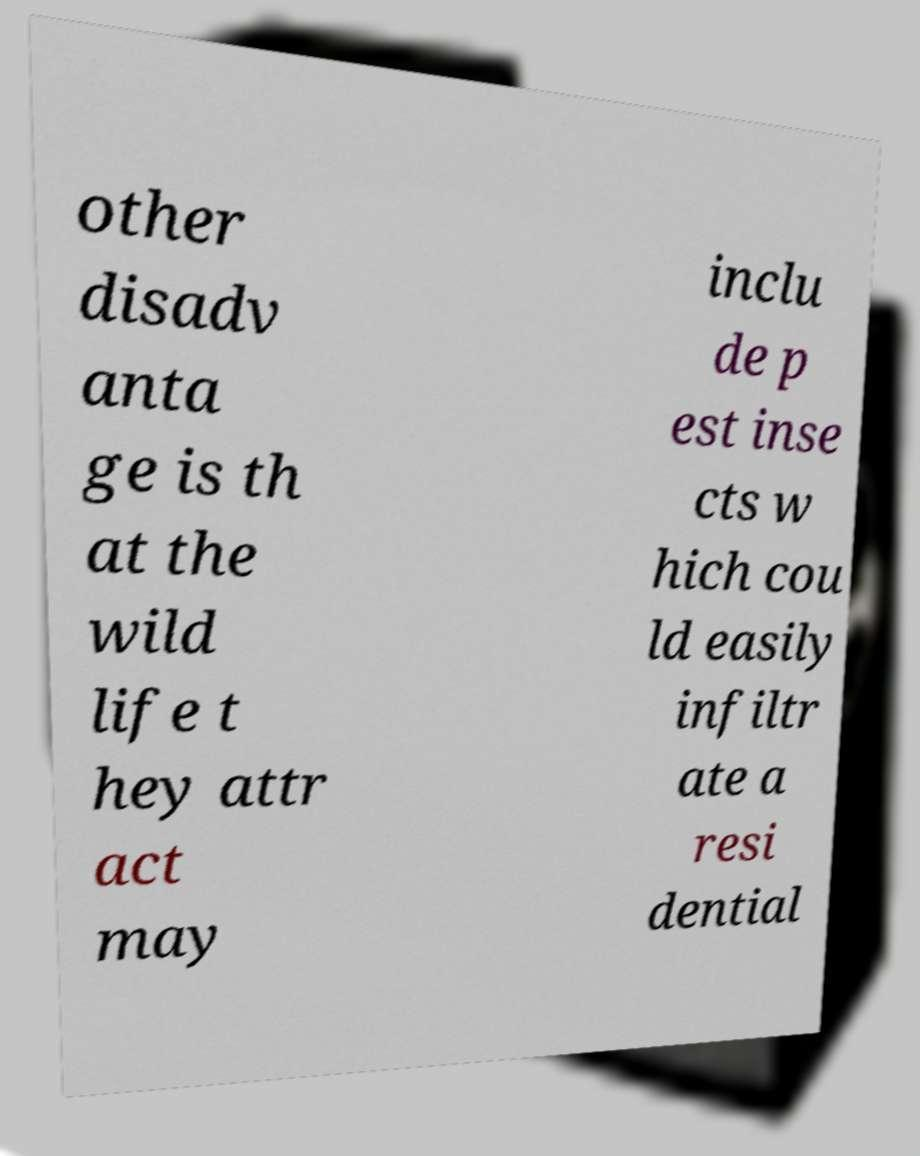Please read and relay the text visible in this image. What does it say? other disadv anta ge is th at the wild life t hey attr act may inclu de p est inse cts w hich cou ld easily infiltr ate a resi dential 